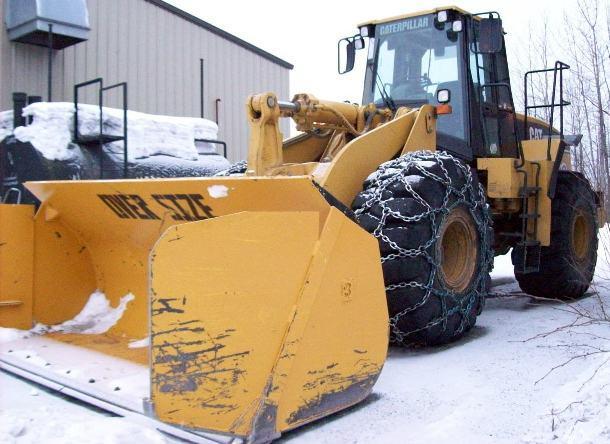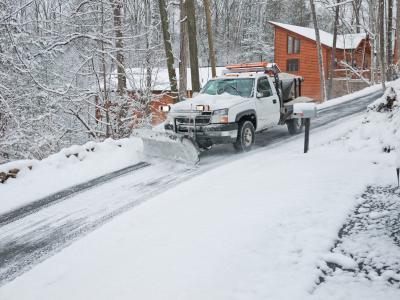The first image is the image on the left, the second image is the image on the right. Analyze the images presented: Is the assertion "The vehicle in the right image is driving in front of a house" valid? Answer yes or no. Yes. 